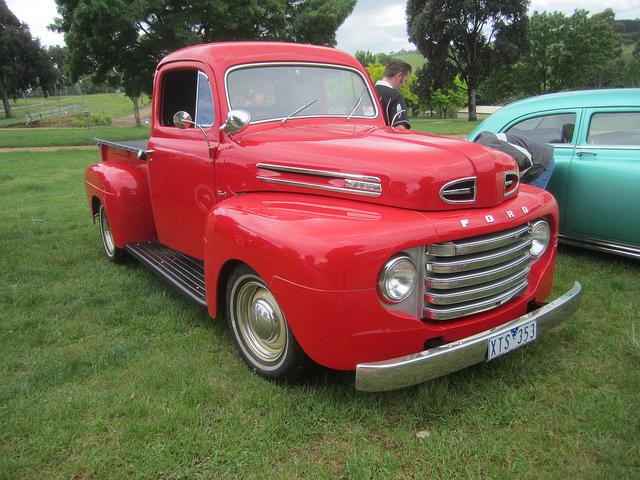What does the license plate say?
Keep it brief. Xts 353. What kind of vehicle is this?
Write a very short answer. Truck. Is this a 2015 model car?
Answer briefly. No. 